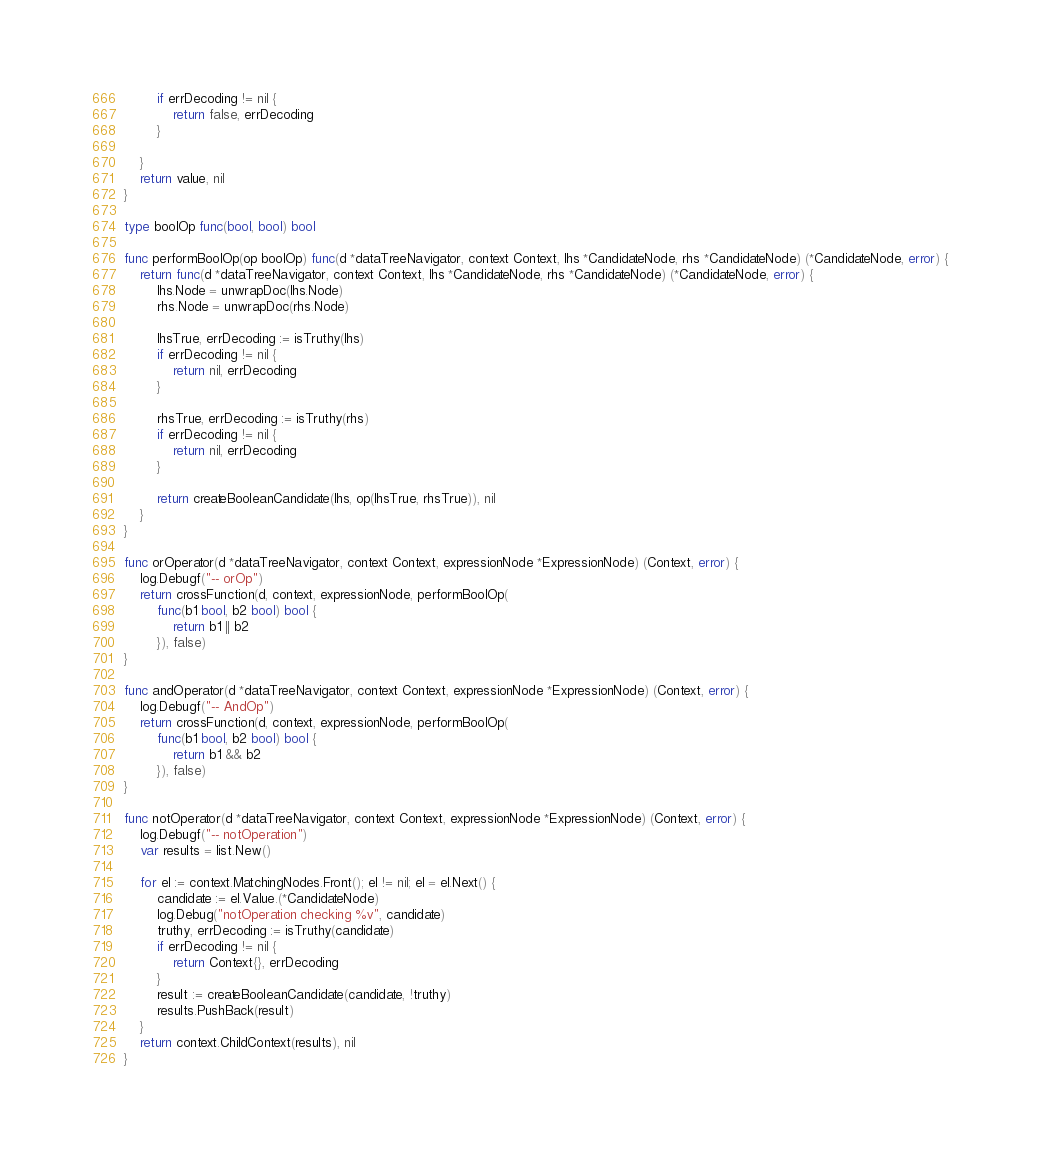Convert code to text. <code><loc_0><loc_0><loc_500><loc_500><_Go_>		if errDecoding != nil {
			return false, errDecoding
		}

	}
	return value, nil
}

type boolOp func(bool, bool) bool

func performBoolOp(op boolOp) func(d *dataTreeNavigator, context Context, lhs *CandidateNode, rhs *CandidateNode) (*CandidateNode, error) {
	return func(d *dataTreeNavigator, context Context, lhs *CandidateNode, rhs *CandidateNode) (*CandidateNode, error) {
		lhs.Node = unwrapDoc(lhs.Node)
		rhs.Node = unwrapDoc(rhs.Node)

		lhsTrue, errDecoding := isTruthy(lhs)
		if errDecoding != nil {
			return nil, errDecoding
		}

		rhsTrue, errDecoding := isTruthy(rhs)
		if errDecoding != nil {
			return nil, errDecoding
		}

		return createBooleanCandidate(lhs, op(lhsTrue, rhsTrue)), nil
	}
}

func orOperator(d *dataTreeNavigator, context Context, expressionNode *ExpressionNode) (Context, error) {
	log.Debugf("-- orOp")
	return crossFunction(d, context, expressionNode, performBoolOp(
		func(b1 bool, b2 bool) bool {
			return b1 || b2
		}), false)
}

func andOperator(d *dataTreeNavigator, context Context, expressionNode *ExpressionNode) (Context, error) {
	log.Debugf("-- AndOp")
	return crossFunction(d, context, expressionNode, performBoolOp(
		func(b1 bool, b2 bool) bool {
			return b1 && b2
		}), false)
}

func notOperator(d *dataTreeNavigator, context Context, expressionNode *ExpressionNode) (Context, error) {
	log.Debugf("-- notOperation")
	var results = list.New()

	for el := context.MatchingNodes.Front(); el != nil; el = el.Next() {
		candidate := el.Value.(*CandidateNode)
		log.Debug("notOperation checking %v", candidate)
		truthy, errDecoding := isTruthy(candidate)
		if errDecoding != nil {
			return Context{}, errDecoding
		}
		result := createBooleanCandidate(candidate, !truthy)
		results.PushBack(result)
	}
	return context.ChildContext(results), nil
}
</code> 